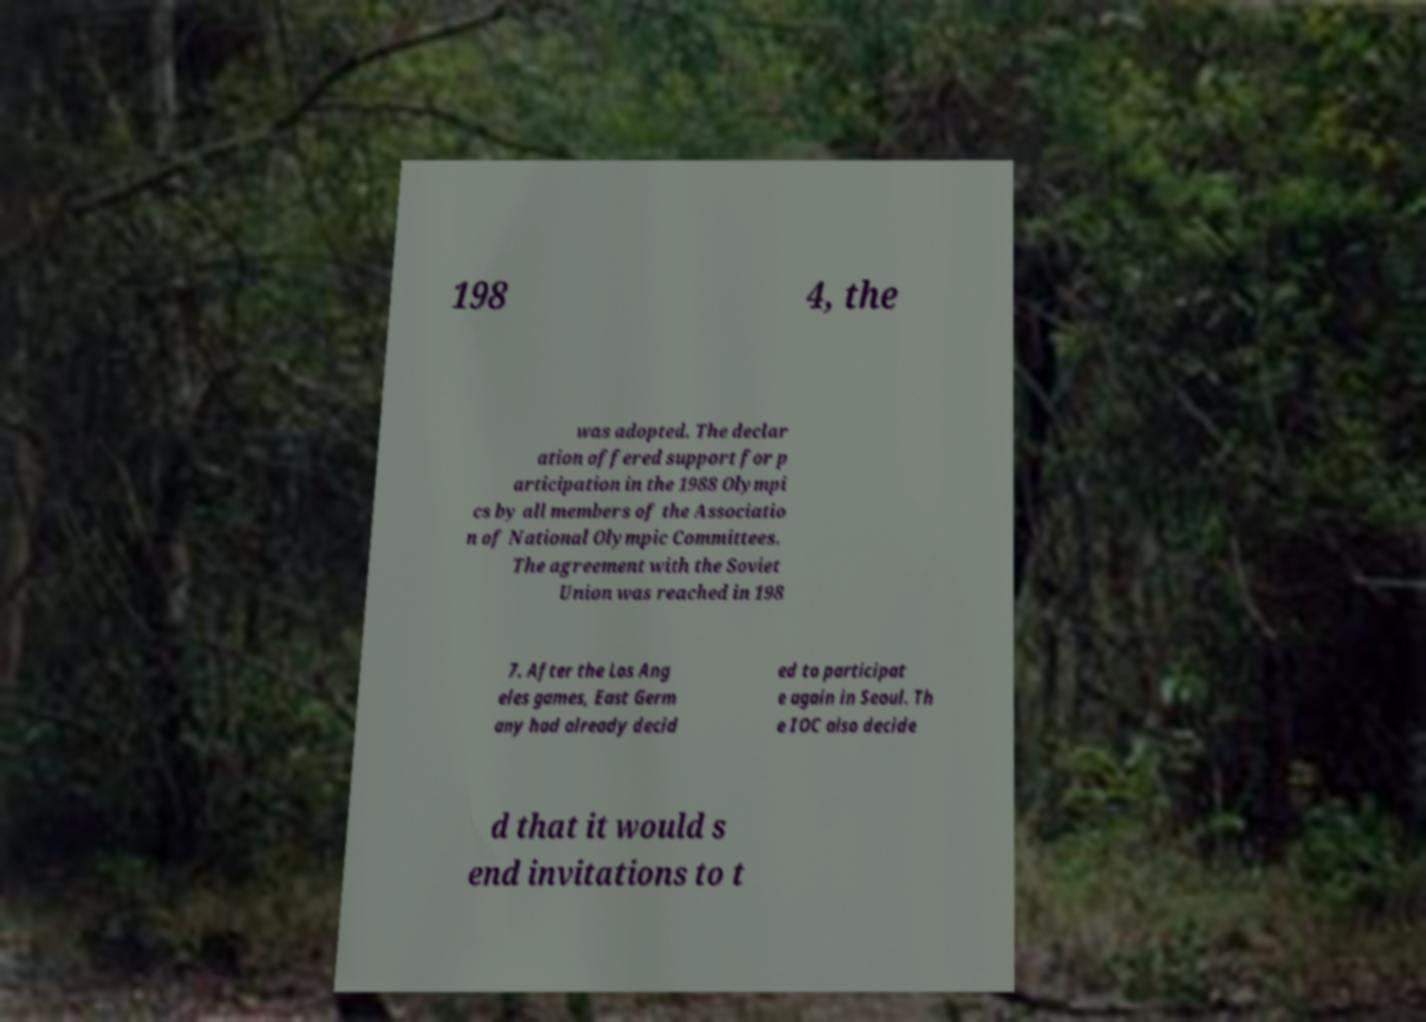Can you accurately transcribe the text from the provided image for me? 198 4, the was adopted. The declar ation offered support for p articipation in the 1988 Olympi cs by all members of the Associatio n of National Olympic Committees. The agreement with the Soviet Union was reached in 198 7. After the Los Ang eles games, East Germ any had already decid ed to participat e again in Seoul. Th e IOC also decide d that it would s end invitations to t 